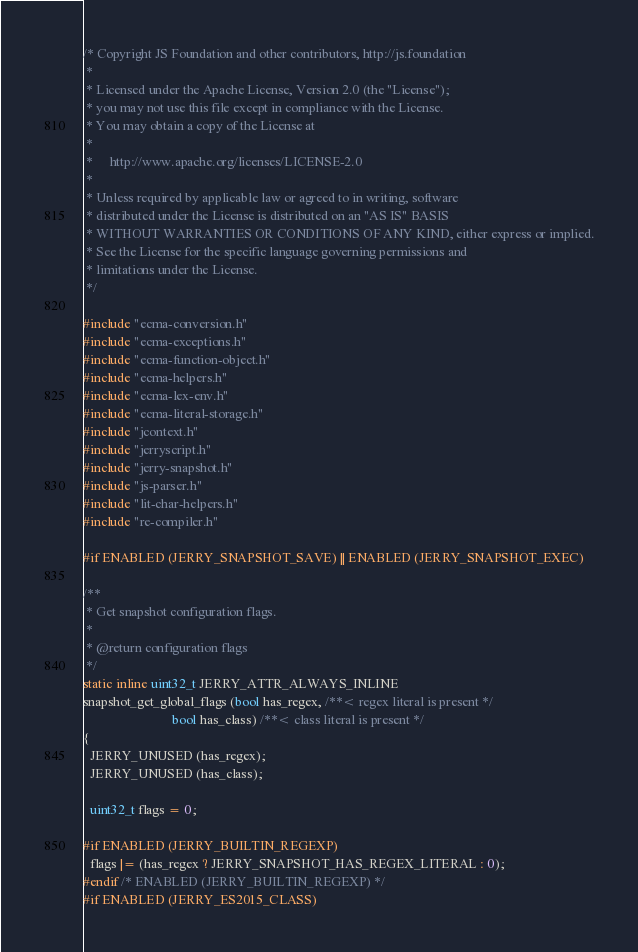<code> <loc_0><loc_0><loc_500><loc_500><_C_>/* Copyright JS Foundation and other contributors, http://js.foundation
 *
 * Licensed under the Apache License, Version 2.0 (the "License");
 * you may not use this file except in compliance with the License.
 * You may obtain a copy of the License at
 *
 *     http://www.apache.org/licenses/LICENSE-2.0
 *
 * Unless required by applicable law or agreed to in writing, software
 * distributed under the License is distributed on an "AS IS" BASIS
 * WITHOUT WARRANTIES OR CONDITIONS OF ANY KIND, either express or implied.
 * See the License for the specific language governing permissions and
 * limitations under the License.
 */

#include "ecma-conversion.h"
#include "ecma-exceptions.h"
#include "ecma-function-object.h"
#include "ecma-helpers.h"
#include "ecma-lex-env.h"
#include "ecma-literal-storage.h"
#include "jcontext.h"
#include "jerryscript.h"
#include "jerry-snapshot.h"
#include "js-parser.h"
#include "lit-char-helpers.h"
#include "re-compiler.h"

#if ENABLED (JERRY_SNAPSHOT_SAVE) || ENABLED (JERRY_SNAPSHOT_EXEC)

/**
 * Get snapshot configuration flags.
 *
 * @return configuration flags
 */
static inline uint32_t JERRY_ATTR_ALWAYS_INLINE
snapshot_get_global_flags (bool has_regex, /**< regex literal is present */
                           bool has_class) /**< class literal is present */
{
  JERRY_UNUSED (has_regex);
  JERRY_UNUSED (has_class);

  uint32_t flags = 0;

#if ENABLED (JERRY_BUILTIN_REGEXP)
  flags |= (has_regex ? JERRY_SNAPSHOT_HAS_REGEX_LITERAL : 0);
#endif /* ENABLED (JERRY_BUILTIN_REGEXP) */
#if ENABLED (JERRY_ES2015_CLASS)</code> 